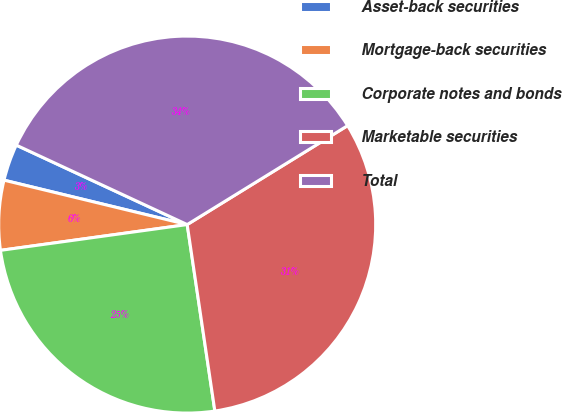Convert chart. <chart><loc_0><loc_0><loc_500><loc_500><pie_chart><fcel>Asset-back securities<fcel>Mortgage-back securities<fcel>Corporate notes and bonds<fcel>Marketable securities<fcel>Total<nl><fcel>3.14%<fcel>5.97%<fcel>25.16%<fcel>31.45%<fcel>34.28%<nl></chart> 